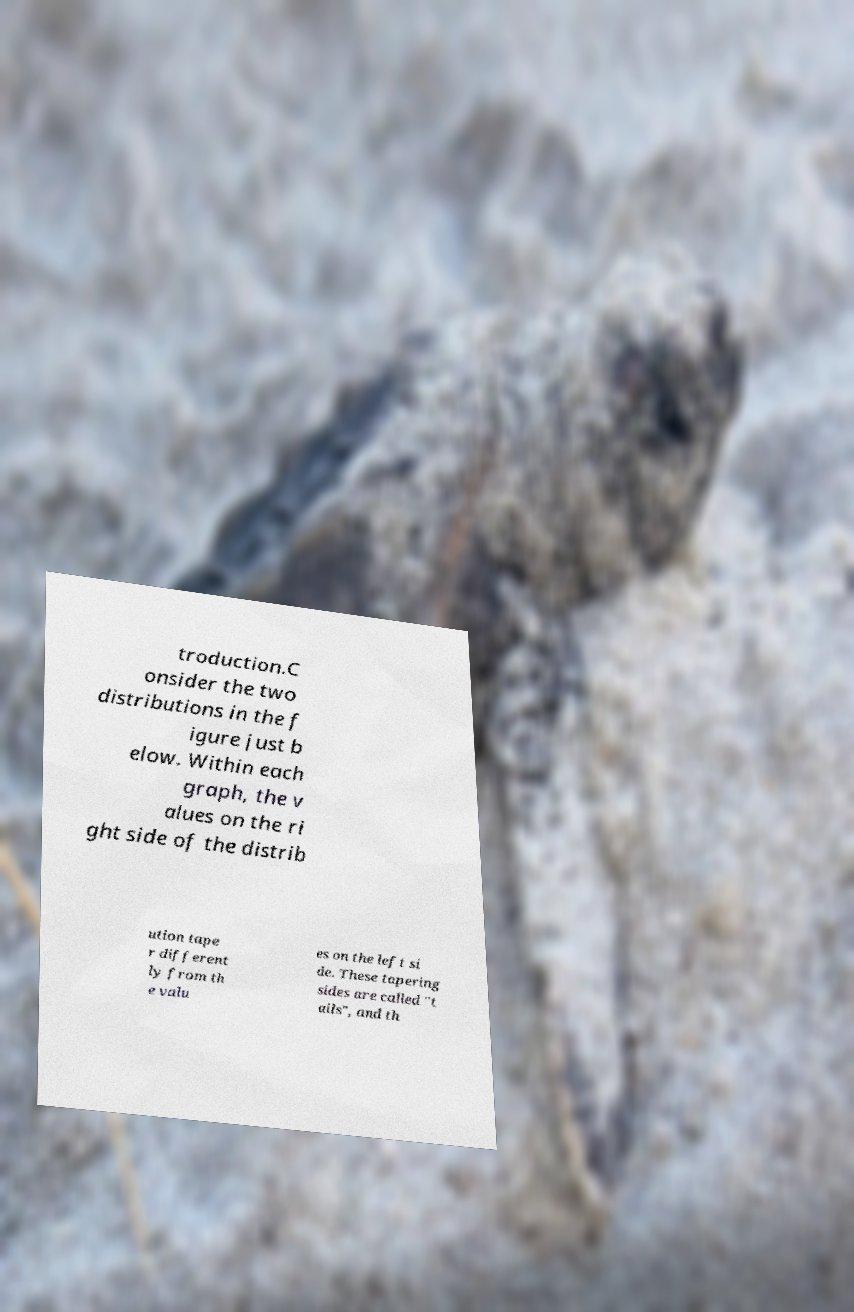Could you extract and type out the text from this image? troduction.C onsider the two distributions in the f igure just b elow. Within each graph, the v alues on the ri ght side of the distrib ution tape r different ly from th e valu es on the left si de. These tapering sides are called "t ails", and th 